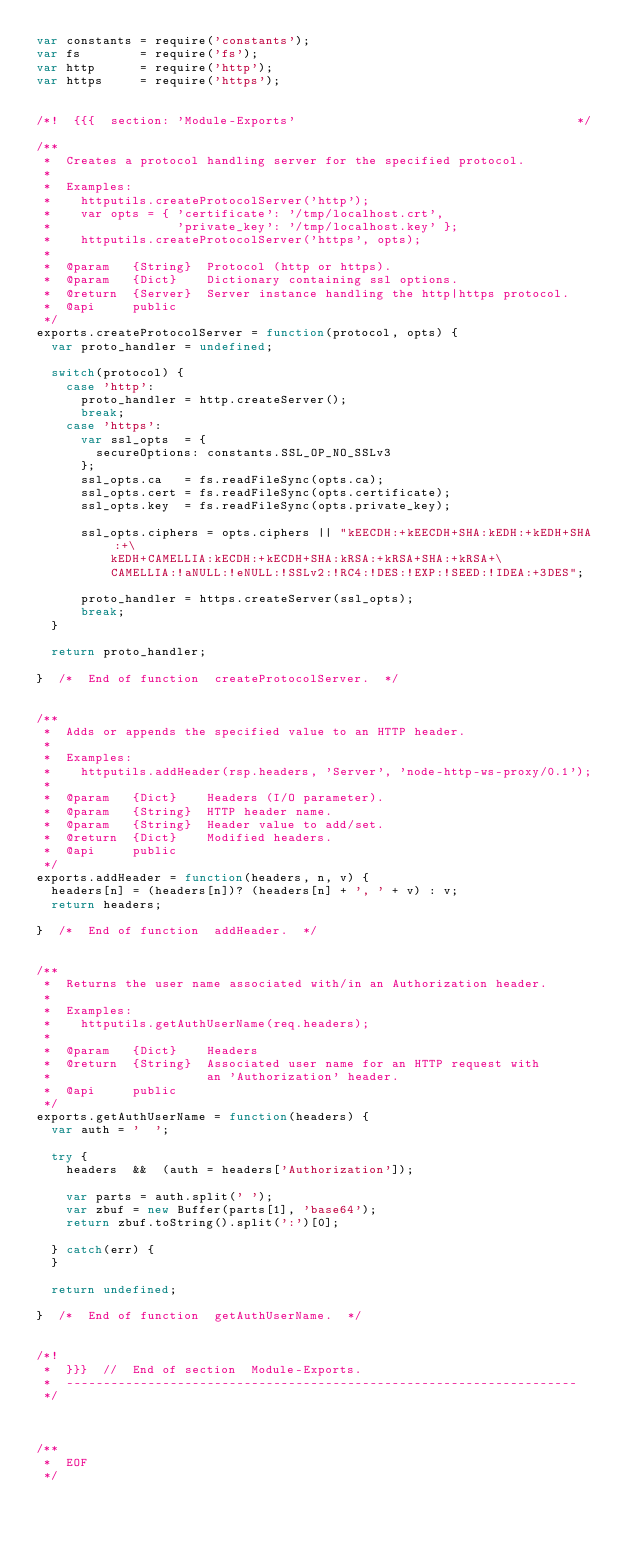Convert code to text. <code><loc_0><loc_0><loc_500><loc_500><_JavaScript_>var constants = require('constants');
var fs        = require('fs');
var http      = require('http');
var https     = require('https');


/*!  {{{  section: 'Module-Exports'                                      */

/**
 *  Creates a protocol handling server for the specified protocol.
 *
 *  Examples:
 *    httputils.createProtocolServer('http');
 *    var opts = { 'certificate': '/tmp/localhost.crt',
 *                 'private_key': '/tmp/localhost.key' };
 *    httputils.createProtocolServer('https', opts);
 *
 *  @param   {String}  Protocol (http or https).
 *  @param   {Dict}    Dictionary containing ssl options.
 *  @return  {Server}  Server instance handling the http|https protocol.
 *  @api     public
 */
exports.createProtocolServer = function(protocol, opts) {
  var proto_handler = undefined;

  switch(protocol) {
    case 'http':
      proto_handler = http.createServer();
      break;
    case 'https':
      var ssl_opts  = {
        secureOptions: constants.SSL_OP_NO_SSLv3
      };
      ssl_opts.ca   = fs.readFileSync(opts.ca);
      ssl_opts.cert = fs.readFileSync(opts.certificate);
      ssl_opts.key  = fs.readFileSync(opts.private_key);

      ssl_opts.ciphers = opts.ciphers || "kEECDH:+kEECDH+SHA:kEDH:+kEDH+SHA:+\
          kEDH+CAMELLIA:kECDH:+kECDH+SHA:kRSA:+kRSA+SHA:+kRSA+\
          CAMELLIA:!aNULL:!eNULL:!SSLv2:!RC4:!DES:!EXP:!SEED:!IDEA:+3DES";

      proto_handler = https.createServer(ssl_opts);
      break;
  }

  return proto_handler;

}  /*  End of function  createProtocolServer.  */


/**
 *  Adds or appends the specified value to an HTTP header.
 *
 *  Examples:
 *    httputils.addHeader(rsp.headers, 'Server', 'node-http-ws-proxy/0.1');
 *
 *  @param   {Dict}    Headers (I/O parameter).
 *  @param   {String}  HTTP header name.
 *  @param   {String}  Header value to add/set.
 *  @return  {Dict}    Modified headers.
 *  @api     public
 */
exports.addHeader = function(headers, n, v) {
  headers[n] = (headers[n])? (headers[n] + ', ' + v) : v;
  return headers;

}  /*  End of function  addHeader.  */


/**
 *  Returns the user name associated with/in an Authorization header.
 *
 *  Examples:
 *    httputils.getAuthUserName(req.headers);
 *
 *  @param   {Dict}    Headers
 *  @return  {String}  Associated user name for an HTTP request with
 *                     an 'Authorization' header.
 *  @api     public
 */
exports.getAuthUserName = function(headers) {
  var auth = '  ';

  try {
    headers  &&  (auth = headers['Authorization']);

    var parts = auth.split(' ');
    var zbuf = new Buffer(parts[1], 'base64');
    return zbuf.toString().split(':')[0];

  } catch(err) {
  }

  return undefined;

}  /*  End of function  getAuthUserName.  */


/*!
 *  }}}  //  End of section  Module-Exports.
 *  ---------------------------------------------------------------------
 */



/**
 *  EOF
 */
</code> 